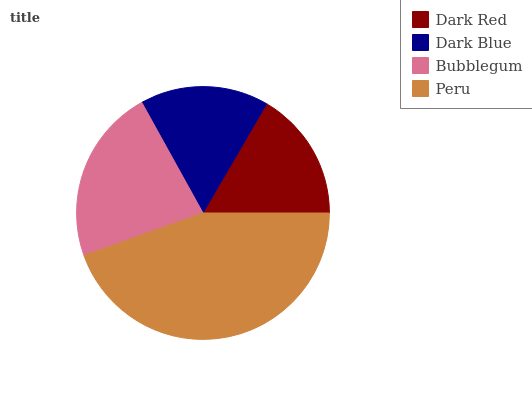Is Dark Blue the minimum?
Answer yes or no. Yes. Is Peru the maximum?
Answer yes or no. Yes. Is Bubblegum the minimum?
Answer yes or no. No. Is Bubblegum the maximum?
Answer yes or no. No. Is Bubblegum greater than Dark Blue?
Answer yes or no. Yes. Is Dark Blue less than Bubblegum?
Answer yes or no. Yes. Is Dark Blue greater than Bubblegum?
Answer yes or no. No. Is Bubblegum less than Dark Blue?
Answer yes or no. No. Is Bubblegum the high median?
Answer yes or no. Yes. Is Dark Red the low median?
Answer yes or no. Yes. Is Peru the high median?
Answer yes or no. No. Is Peru the low median?
Answer yes or no. No. 